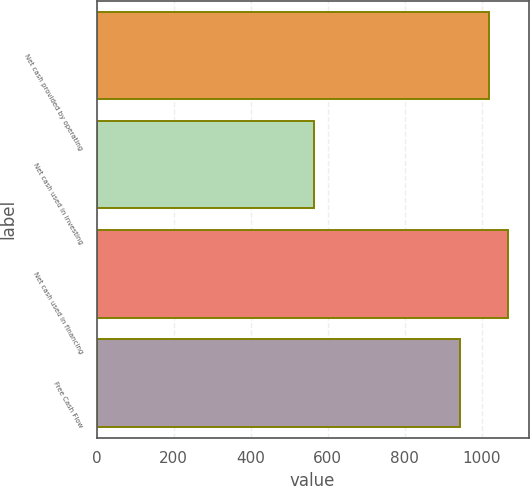<chart> <loc_0><loc_0><loc_500><loc_500><bar_chart><fcel>Net cash provided by operating<fcel>Net cash used in investing<fcel>Net cash used in financing<fcel>Free Cash Flow<nl><fcel>1018.6<fcel>564.9<fcel>1068.56<fcel>944<nl></chart> 